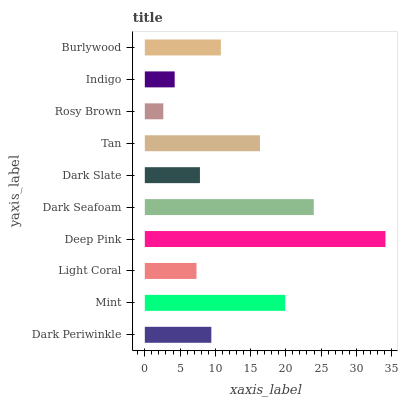Is Rosy Brown the minimum?
Answer yes or no. Yes. Is Deep Pink the maximum?
Answer yes or no. Yes. Is Mint the minimum?
Answer yes or no. No. Is Mint the maximum?
Answer yes or no. No. Is Mint greater than Dark Periwinkle?
Answer yes or no. Yes. Is Dark Periwinkle less than Mint?
Answer yes or no. Yes. Is Dark Periwinkle greater than Mint?
Answer yes or no. No. Is Mint less than Dark Periwinkle?
Answer yes or no. No. Is Burlywood the high median?
Answer yes or no. Yes. Is Dark Periwinkle the low median?
Answer yes or no. Yes. Is Dark Periwinkle the high median?
Answer yes or no. No. Is Indigo the low median?
Answer yes or no. No. 